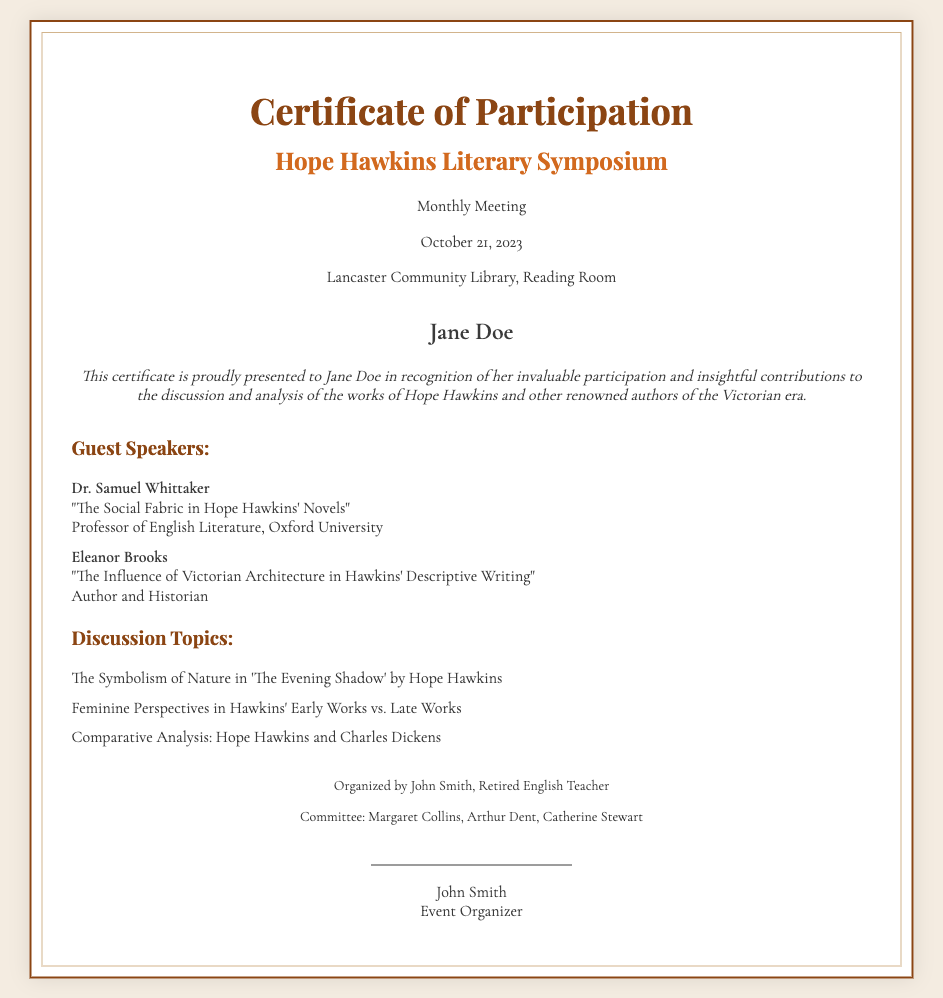What is the name of the symposium? The symposium is specifically called "Hope Hawkins Literary Symposium," as stated in the title of the document.
Answer: Hope Hawkins Literary Symposium Who is the participant named on the certificate? The certificate prominently displays the participant's name, which is featured in a bold format.
Answer: Jane Doe What date was the monthly meeting held? The certificate provides the date of the meeting directly, which is listed in the header section.
Answer: October 21, 2023 Who organized the event? The organizer's name is mentioned at the bottom of the certificate, identifying the person responsible for organizing the event.
Answer: John Smith How many guest speakers are listed in the document? The document includes information about the guest speakers in a specific section, detailing two speakers.
Answer: 2 What is one of the discussion topics related to Hope Hawkins' work? The document lists several discussion topics, one of which involves analyzing a specific work by Hawkins.
Answer: The Symbolism of Nature in 'The Evening Shadow' by Hope Hawkins What is the location of the meeting? The location of the meeting is given in the header part of the certificate under the date.
Answer: Lancaster Community Library, Reading Room What is the title of Dr. Samuel Whittaker's lecture? The title of the lecture can be found under the guest speaker's name in the speakers' section.
Answer: The Social Fabric in Hope Hawkins' Novels Who is part of the committee organizing the symposium? The committee members are listed in the footer, showing names of all involved in organizing the event.
Answer: Margaret Collins, Arthur Dent, Catherine Stewart 